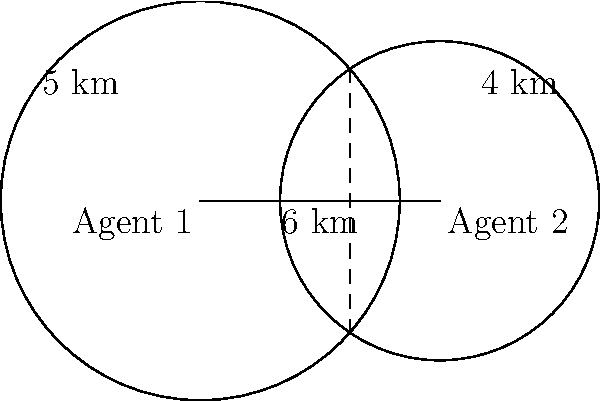Two intelligence officers, Agent 1 and Agent 2, are positioned 6 km apart. Agent 1's communication range covers a circular area with a radius of 5 km, while Agent 2's range covers a circular area with a radius of 4 km. What is the length of the line segment representing the overlapping coverage area between the two agents? To solve this problem, we need to follow these steps:

1) First, we identify that the overlapping area forms a lens shape created by the intersection of two circles.

2) The line segment we're looking for is the chord that forms where these two circles intersect.

3) To find the length of this chord, we can use the formula:

   $$d = 2\sqrt{r_1^2 - a^2}$$

   where $d$ is the chord length, $r_1$ is the radius of one circle, and $a$ is the distance from the center of that circle to the midpoint of the chord.

4) To find $a$, we can use the formula:

   $$a = \frac{r_1^2 - r_2^2 + D^2}{2D}$$

   where $r_1$ and $r_2$ are the radii of the two circles, and $D$ is the distance between their centers.

5) We have:
   $r_1 = 5$ km (Agent 1's range)
   $r_2 = 4$ km (Agent 2's range)
   $D = 6$ km (distance between agents)

6) Plugging these into the formula for $a$:

   $$a = \frac{5^2 - 4^2 + 6^2}{2(6)} = \frac{25 - 16 + 36}{12} = \frac{45}{12} = 3.75$$ km

7) Now we can use this to find $d$:

   $$d = 2\sqrt{5^2 - 3.75^2} = 2\sqrt{25 - 14.0625} = 2\sqrt{10.9375} \approx 6.61$$ km

Therefore, the length of the line segment representing the overlapping coverage area is approximately 6.61 km.
Answer: 6.61 km 